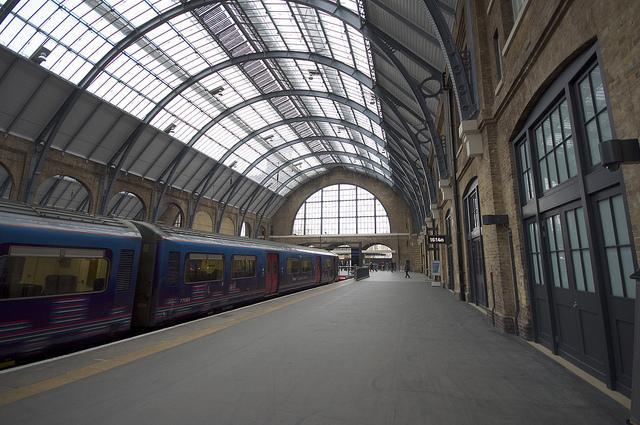What kind of payment is needed for an opportunity to ride this machine? Please explain your reasoning. fare. People need to pay fare. 